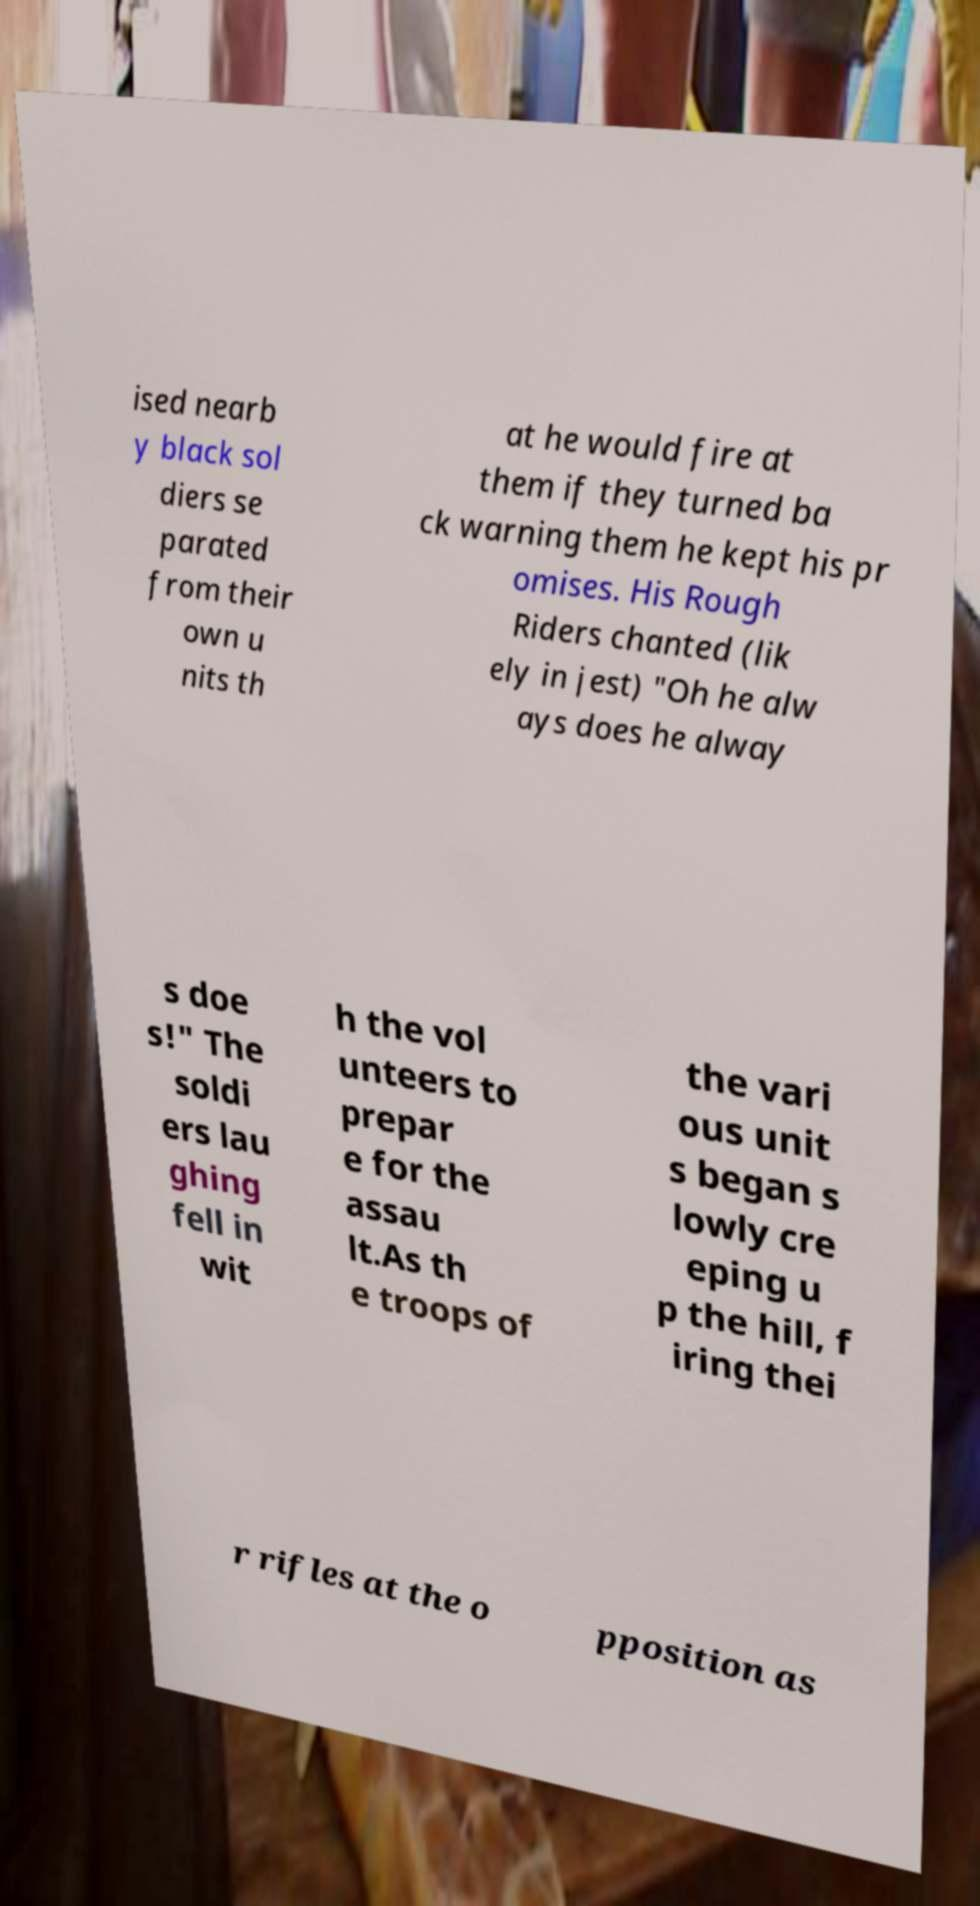Please read and relay the text visible in this image. What does it say? ised nearb y black sol diers se parated from their own u nits th at he would fire at them if they turned ba ck warning them he kept his pr omises. His Rough Riders chanted (lik ely in jest) "Oh he alw ays does he alway s doe s!" The soldi ers lau ghing fell in wit h the vol unteers to prepar e for the assau lt.As th e troops of the vari ous unit s began s lowly cre eping u p the hill, f iring thei r rifles at the o pposition as 